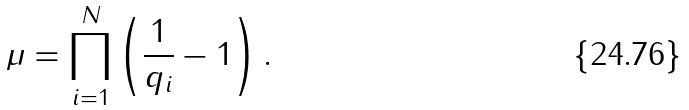<formula> <loc_0><loc_0><loc_500><loc_500>\mu = \prod _ { i = 1 } ^ { N } \left ( \frac { 1 } { q _ { i } } - 1 \right ) .</formula> 